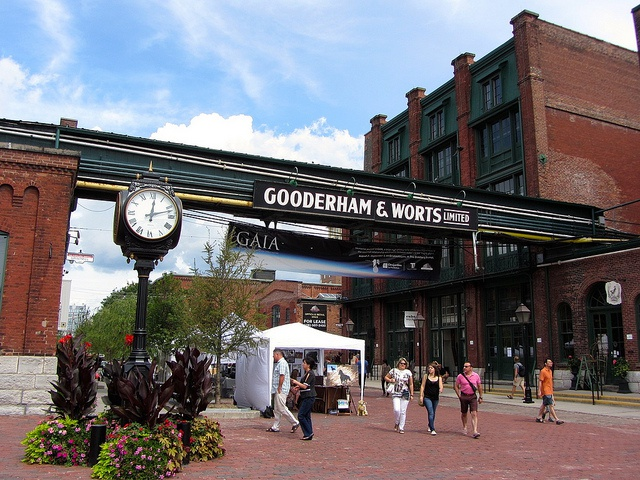Describe the objects in this image and their specific colors. I can see clock in lightblue, white, darkgray, gray, and black tones, people in lightblue, brown, black, and maroon tones, people in lightblue, lightgray, gray, and darkgray tones, people in lightblue, darkgray, lightgray, and gray tones, and people in lightblue, black, brown, gray, and maroon tones in this image. 